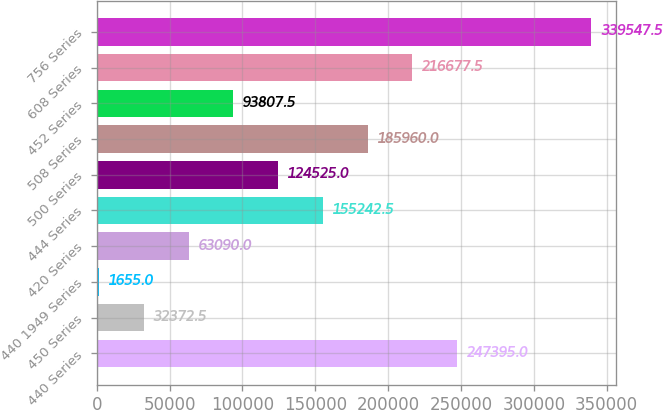Convert chart to OTSL. <chart><loc_0><loc_0><loc_500><loc_500><bar_chart><fcel>440 Series<fcel>450 Series<fcel>440 1949 Series<fcel>420 Series<fcel>444 Series<fcel>500 Series<fcel>508 Series<fcel>452 Series<fcel>608 Series<fcel>756 Series<nl><fcel>247395<fcel>32372.5<fcel>1655<fcel>63090<fcel>155242<fcel>124525<fcel>185960<fcel>93807.5<fcel>216678<fcel>339548<nl></chart> 